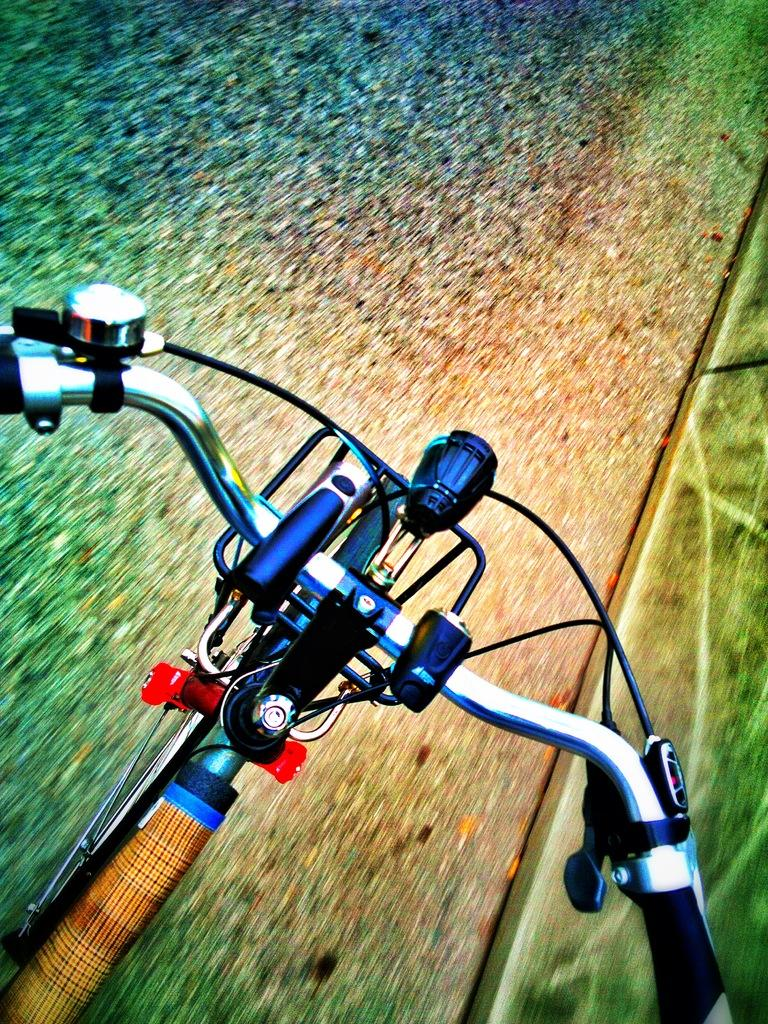What is the main object in the image? There is a bicycle in the image. What features does the bicycle have? The bicycle has a bell and brakes. Where is the bicycle located? The bicycle is on the road. What can be seen on the right side of the image? There is grass on the right side of the image. How many apples are hanging from the bicycle in the image? There are no apples present in the image; it features a bicycle with a bell and brakes on the road. What type of train can be seen passing by in the image? There is no train visible in the image; it only shows a bicycle on the road with grass on the right side. 